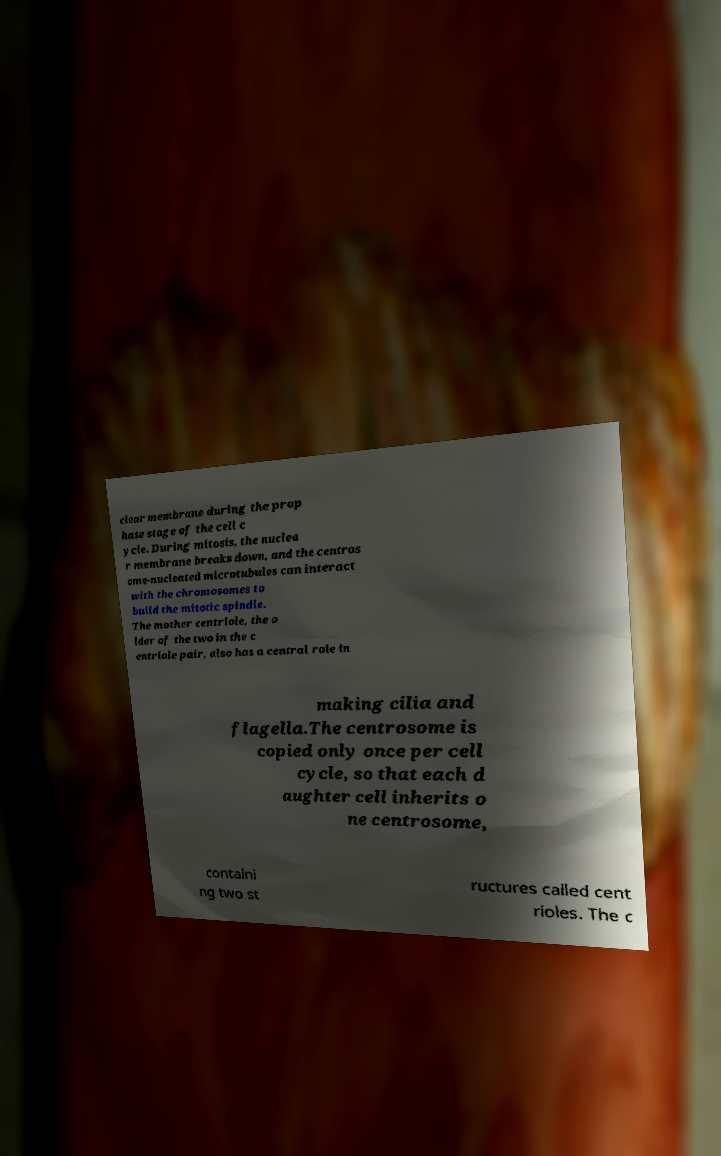I need the written content from this picture converted into text. Can you do that? clear membrane during the prop hase stage of the cell c ycle. During mitosis, the nuclea r membrane breaks down, and the centros ome-nucleated microtubules can interact with the chromosomes to build the mitotic spindle. The mother centriole, the o lder of the two in the c entriole pair, also has a central role in making cilia and flagella.The centrosome is copied only once per cell cycle, so that each d aughter cell inherits o ne centrosome, containi ng two st ructures called cent rioles. The c 